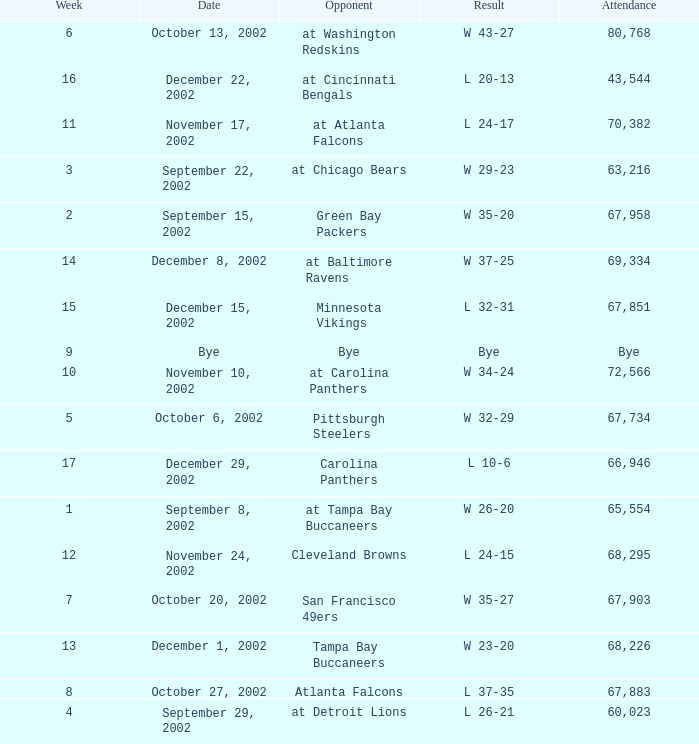Who was the opposing team in the game attended by 65,554? At tampa bay buccaneers. 